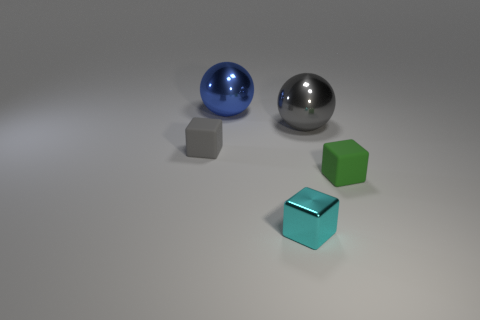Subtract 1 cubes. How many cubes are left? 2 Add 4 tiny brown cubes. How many objects exist? 9 Subtract 0 red blocks. How many objects are left? 5 Subtract all balls. How many objects are left? 3 Subtract all balls. Subtract all matte things. How many objects are left? 1 Add 2 large metal things. How many large metal things are left? 4 Add 5 big gray spheres. How many big gray spheres exist? 6 